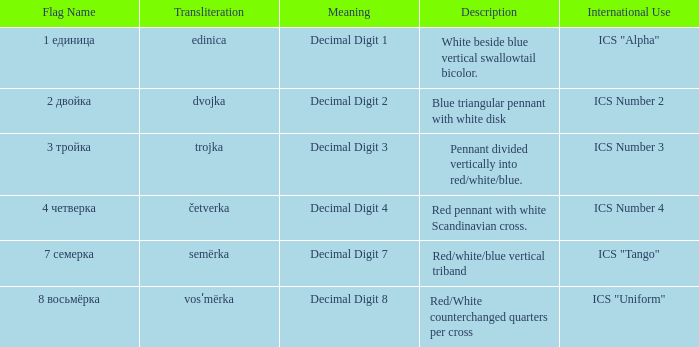What are the meanings of the flag whose name transliterates to semërka? Decimal Digit 7. Give me the full table as a dictionary. {'header': ['Flag Name', 'Transliteration', 'Meaning', 'Description', 'International Use'], 'rows': [['1 единица', 'edinica', 'Decimal Digit 1', 'White beside blue vertical swallowtail bicolor.', 'ICS "Alpha"'], ['2 двойка', 'dvojka', 'Decimal Digit 2', 'Blue triangular pennant with white disk', 'ICS Number 2'], ['3 тройка', 'trojka', 'Decimal Digit 3', 'Pennant divided vertically into red/white/blue.', 'ICS Number 3'], ['4 четверка', 'četverka', 'Decimal Digit 4', 'Red pennant with white Scandinavian cross.', 'ICS Number 4'], ['7 семерка', 'semërka', 'Decimal Digit 7', 'Red/white/blue vertical triband', 'ICS "Tango"'], ['8 восьмёрка', 'vosʹmërka', 'Decimal Digit 8', 'Red/White counterchanged quarters per cross', 'ICS "Uniform"']]} 